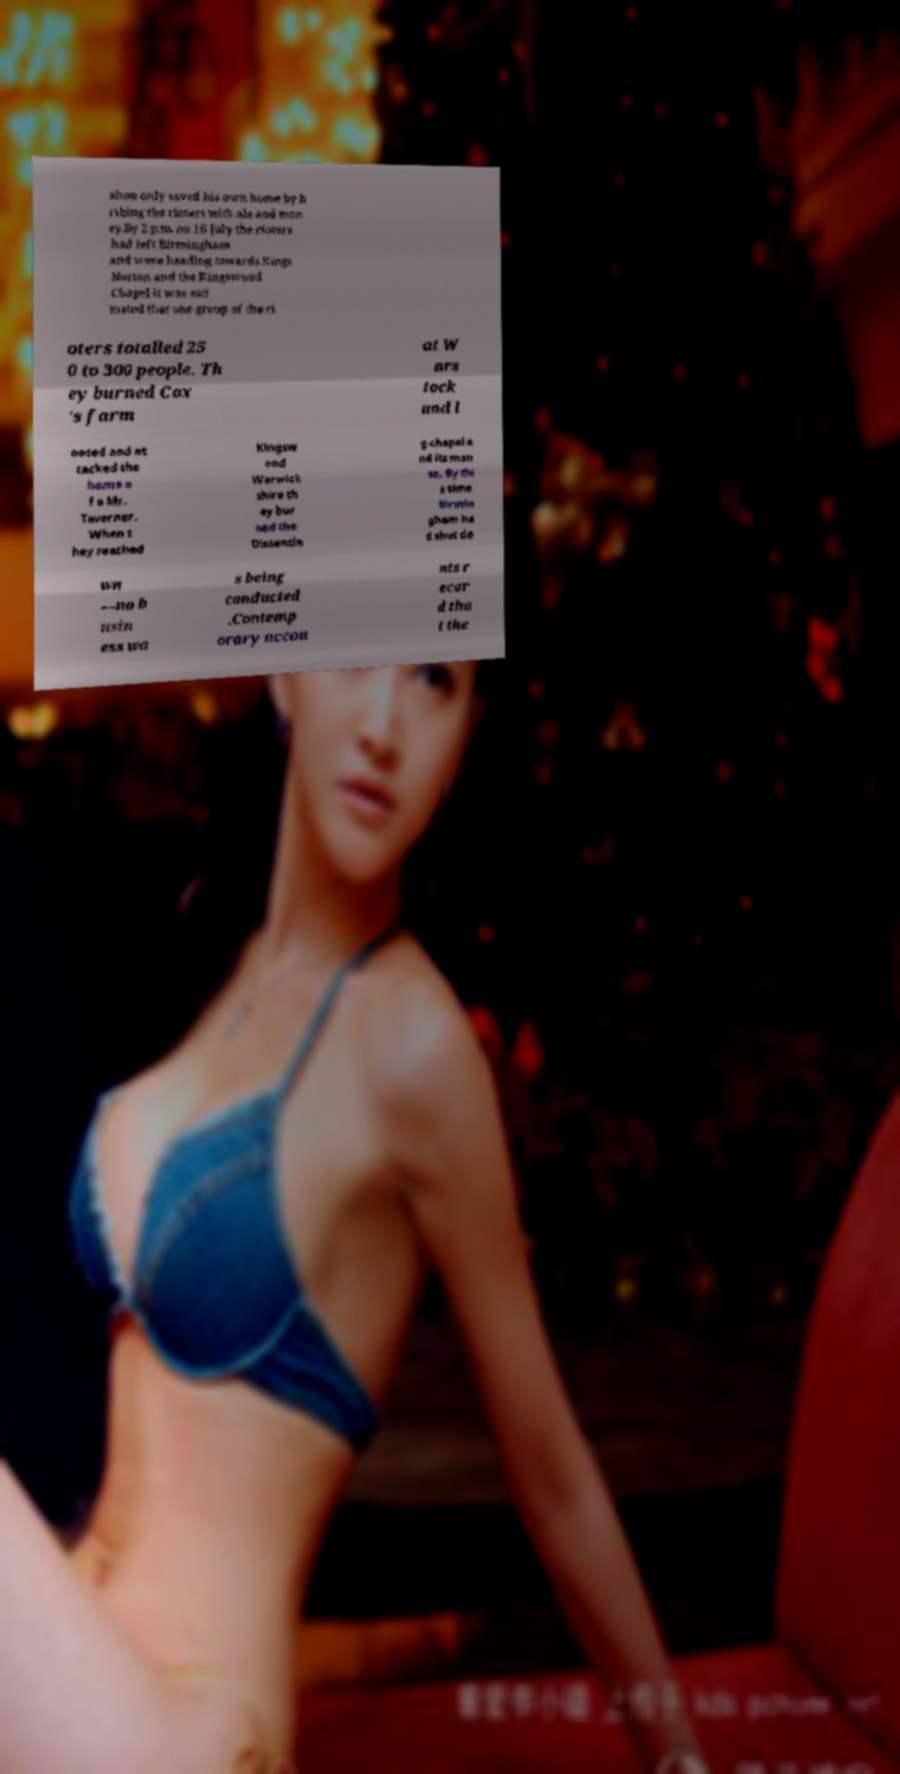For documentation purposes, I need the text within this image transcribed. Could you provide that? alton only saved his own home by b ribing the rioters with ale and mon ey.By 2 p.m. on 16 July the rioters had left Birmingham and were heading towards Kings Norton and the Kingswood Chapel it was esti mated that one group of the ri oters totalled 25 0 to 300 people. Th ey burned Cox 's farm at W ars tock and l ooted and at tacked the home o f a Mr. Taverner. When t hey reached Kingsw ood Warwick shire th ey bur ned the Dissentin g chapel a nd its man se. By thi s time Birmin gham ha d shut do wn —no b usin ess wa s being conducted .Contemp orary accou nts r ecor d tha t the 